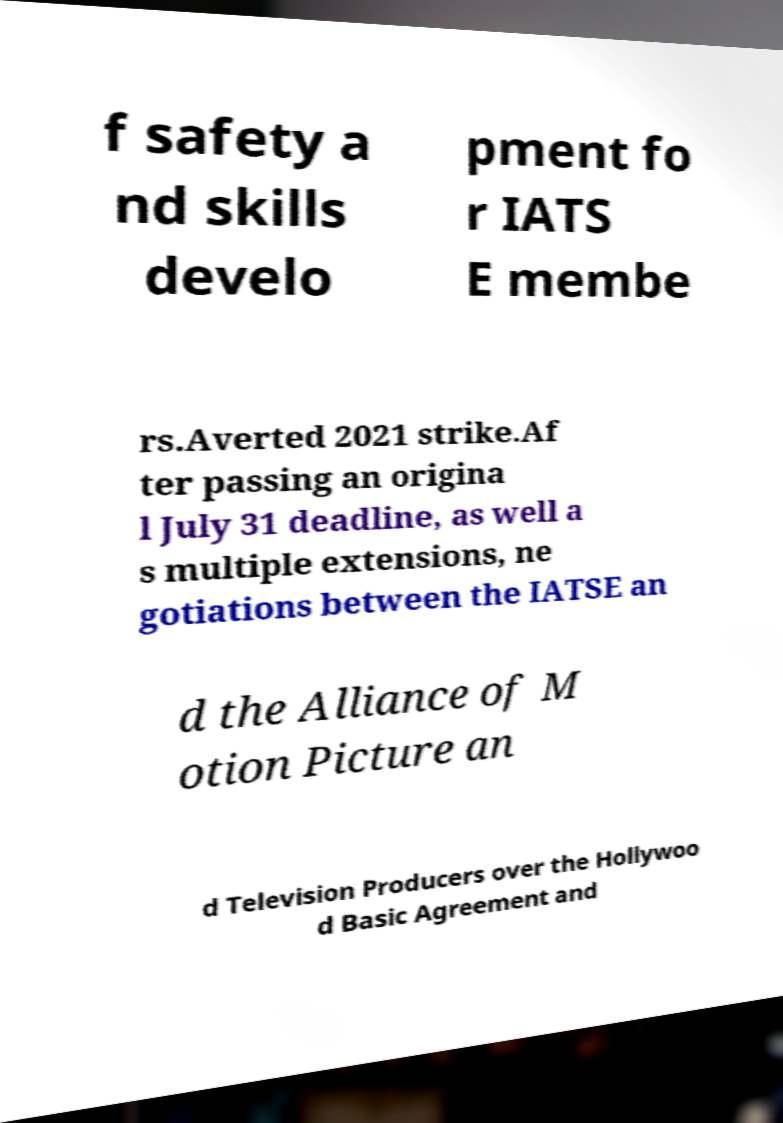Could you extract and type out the text from this image? f safety a nd skills develo pment fo r IATS E membe rs.Averted 2021 strike.Af ter passing an origina l July 31 deadline, as well a s multiple extensions, ne gotiations between the IATSE an d the Alliance of M otion Picture an d Television Producers over the Hollywoo d Basic Agreement and 